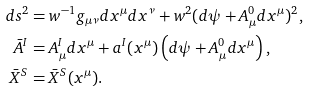<formula> <loc_0><loc_0><loc_500><loc_500>d s ^ { 2 } & = w ^ { - 1 } g _ { \mu \nu } d x ^ { \mu } d x ^ { \nu } + w ^ { 2 } ( d \psi + A ^ { 0 } _ { \mu } d x ^ { \mu } ) ^ { 2 } , \\ \bar { A } ^ { I } & = A ^ { I } _ { \mu } d x ^ { \mu } + a ^ { I } ( x ^ { \mu } ) \left ( d \psi + A ^ { 0 } _ { \mu } d x ^ { \mu } \right ) , \\ { \bar { X } } ^ { S } & = { \bar { X } } ^ { S } ( x ^ { \mu } ) .</formula> 